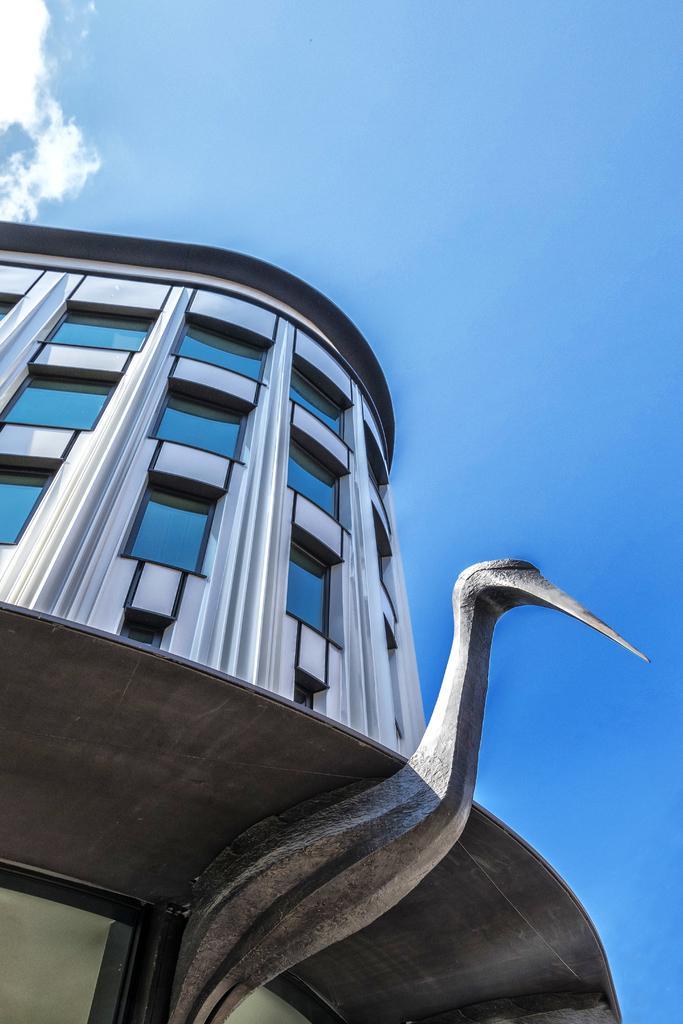Please provide a concise description of this image. At the bottom of this image, there is a bird. In the background, there is a building which is having windows and there are clouds in the sky. 